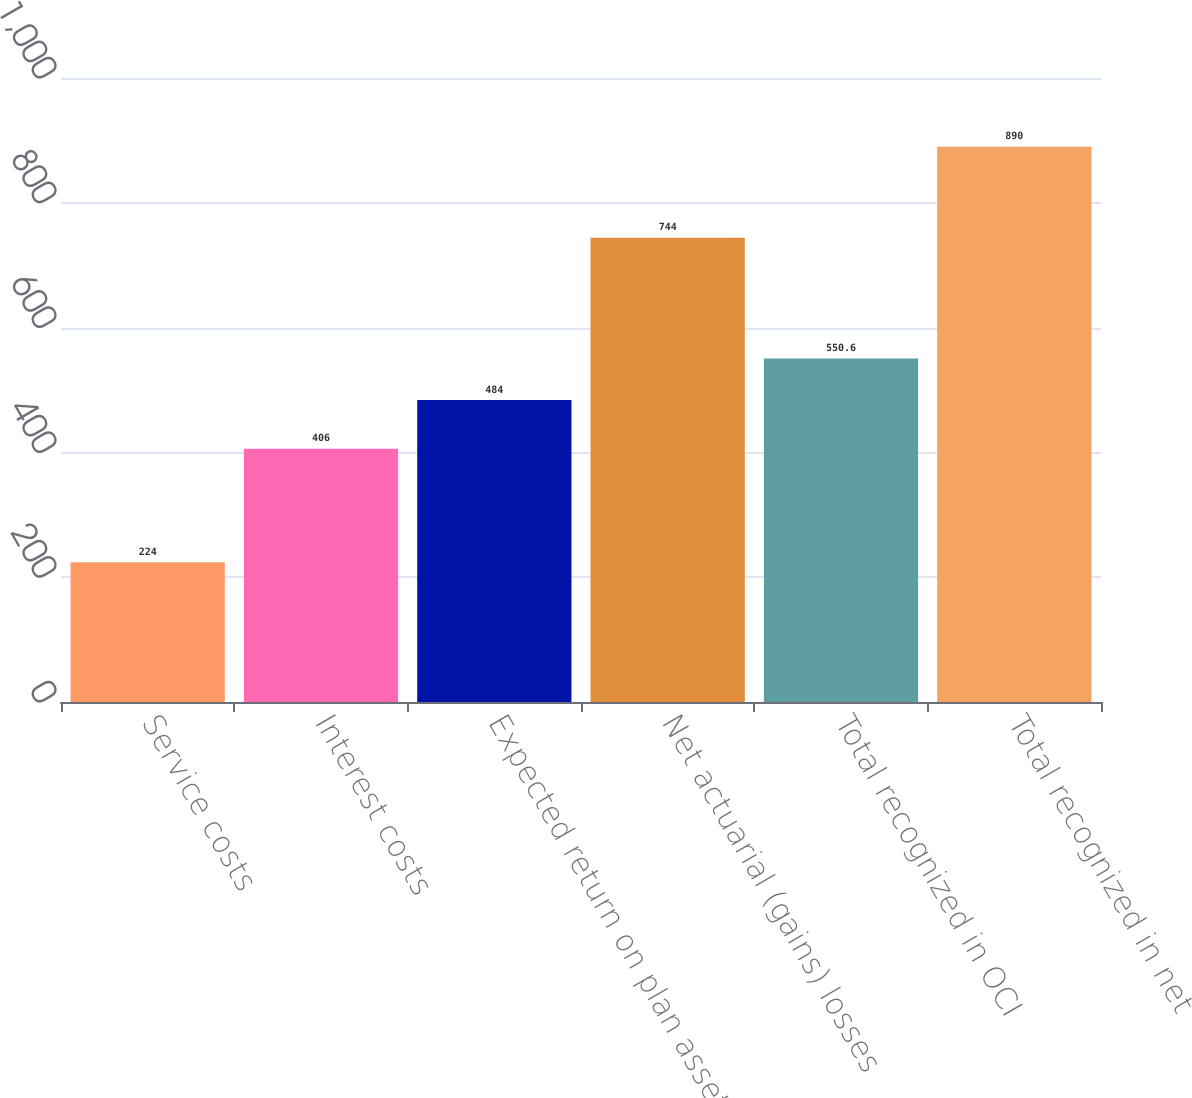Convert chart. <chart><loc_0><loc_0><loc_500><loc_500><bar_chart><fcel>Service costs<fcel>Interest costs<fcel>Expected return on plan assets<fcel>Net actuarial (gains) losses<fcel>Total recognized in OCI<fcel>Total recognized in net<nl><fcel>224<fcel>406<fcel>484<fcel>744<fcel>550.6<fcel>890<nl></chart> 